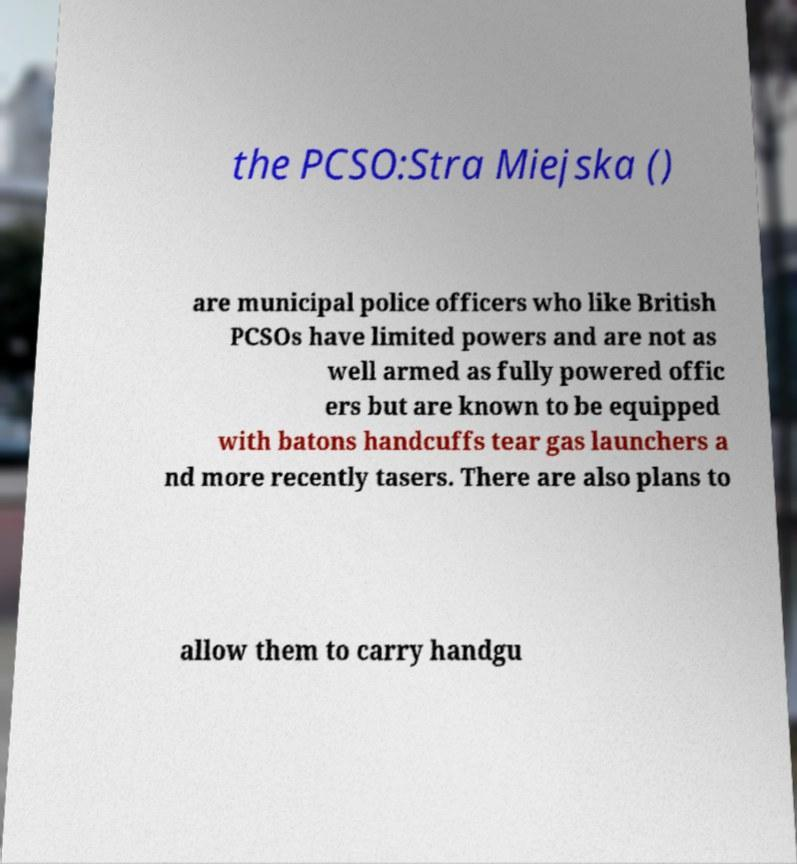Can you accurately transcribe the text from the provided image for me? the PCSO:Stra Miejska () are municipal police officers who like British PCSOs have limited powers and are not as well armed as fully powered offic ers but are known to be equipped with batons handcuffs tear gas launchers a nd more recently tasers. There are also plans to allow them to carry handgu 